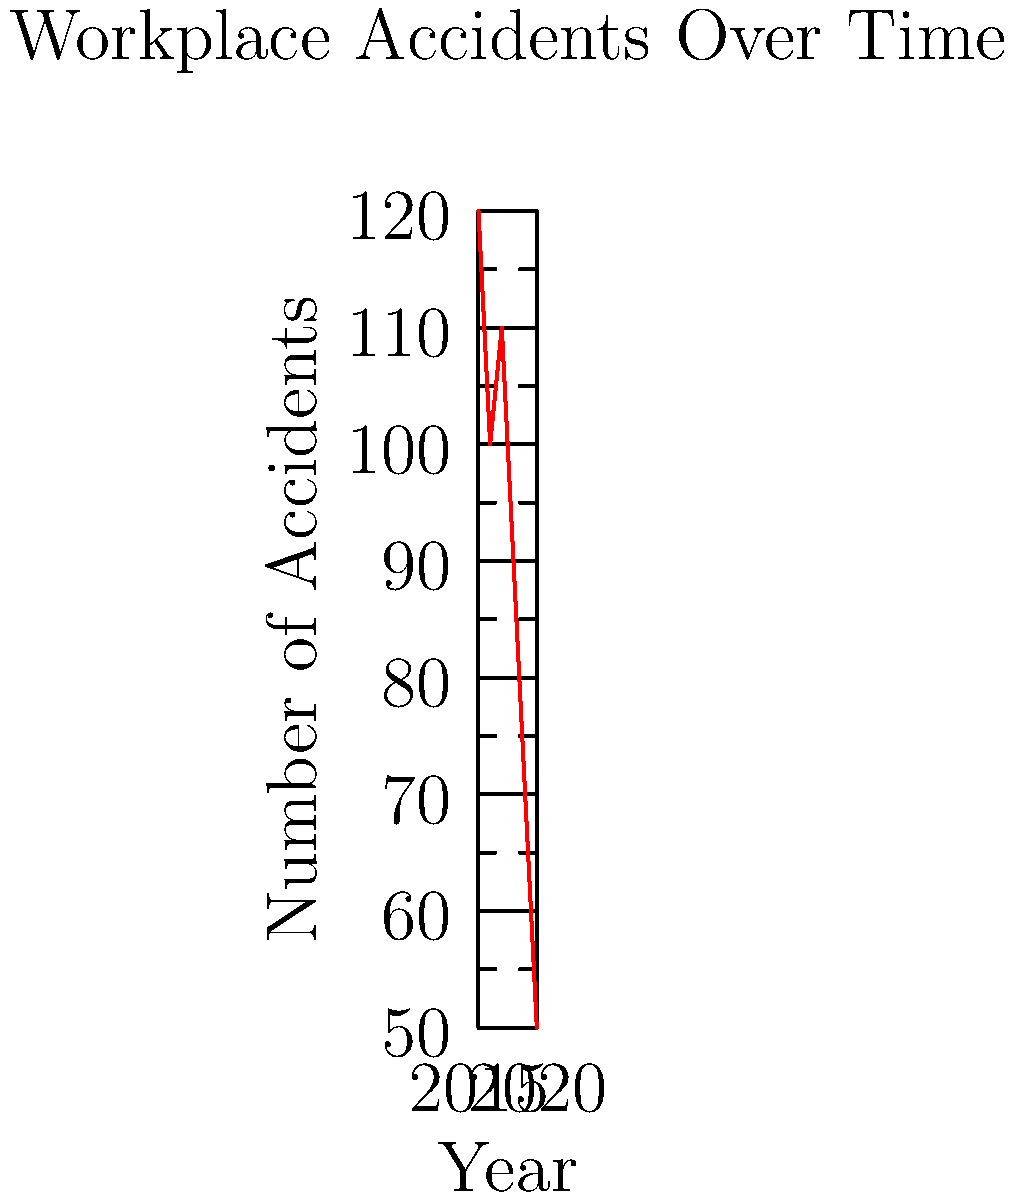Based on the line graph showing workplace accidents from 2015 to 2020, what was the overall trend in accidents, and in which year did the number of accidents peak? To answer this question, we need to analyze the line graph:

1. Overall trend:
   - Start by looking at the general direction of the line from left to right.
   - We can see that the line generally moves downward from 2015 to 2020.
   - This indicates an overall decreasing trend in workplace accidents.

2. Peak year:
   - Examine the highest point on the graph.
   - The graph starts at its highest point in 2015 with 120 accidents.
   - Although there's a slight increase in 2017, it doesn't exceed the 2015 level.
   - Therefore, 2015 is the peak year for workplace accidents.

3. Additional observations:
   - There's a slight increase from 2016 to 2017, but the overall trend continues downward after that.
   - The steepest decline appears to be between 2019 and 2020.
Answer: Overall decreasing trend; peaked in 2015 